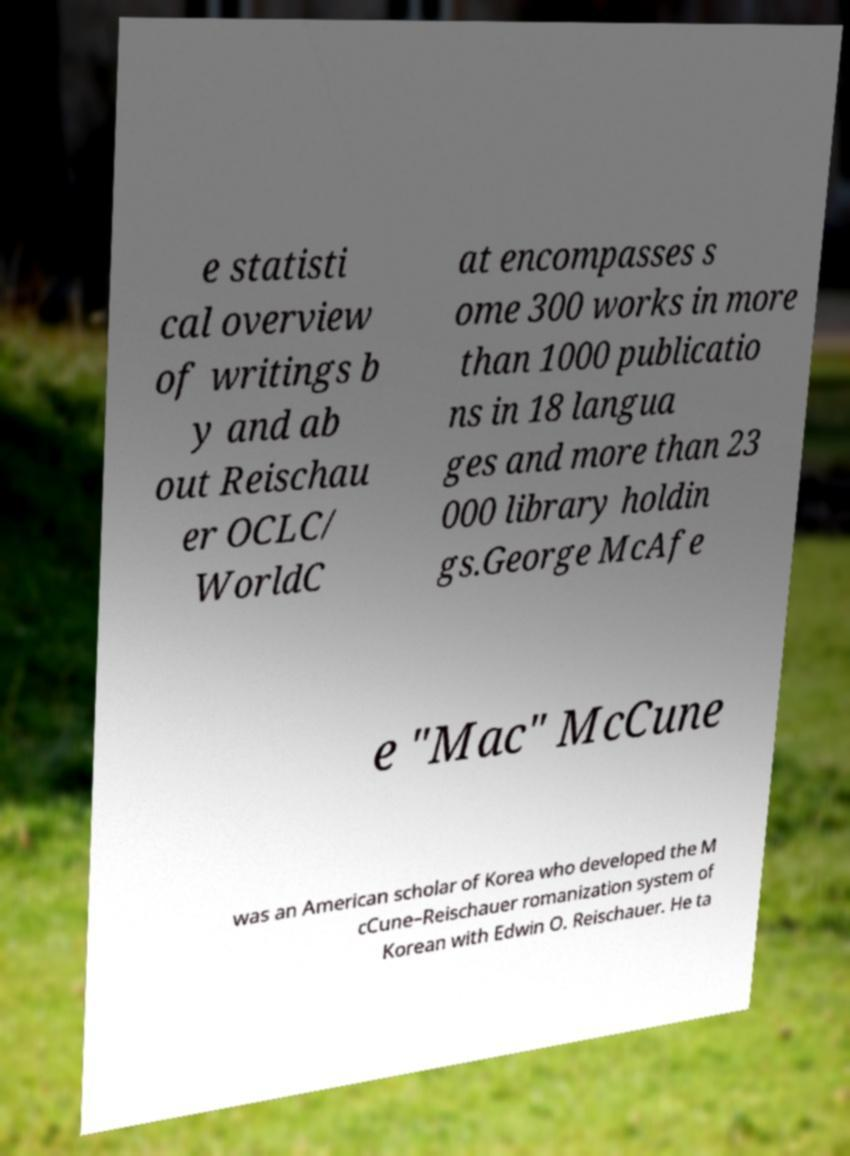I need the written content from this picture converted into text. Can you do that? e statisti cal overview of writings b y and ab out Reischau er OCLC/ WorldC at encompasses s ome 300 works in more than 1000 publicatio ns in 18 langua ges and more than 23 000 library holdin gs.George McAfe e "Mac" McCune was an American scholar of Korea who developed the M cCune–Reischauer romanization system of Korean with Edwin O. Reischauer. He ta 